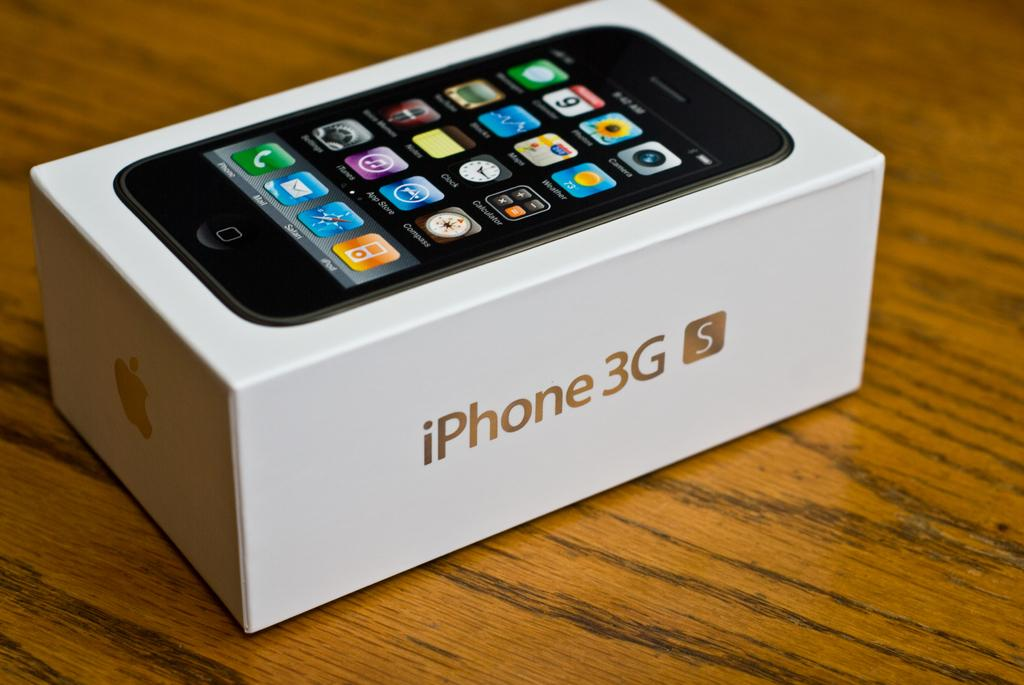<image>
Create a compact narrative representing the image presented. a box for an Iphone 3GS is on a table 